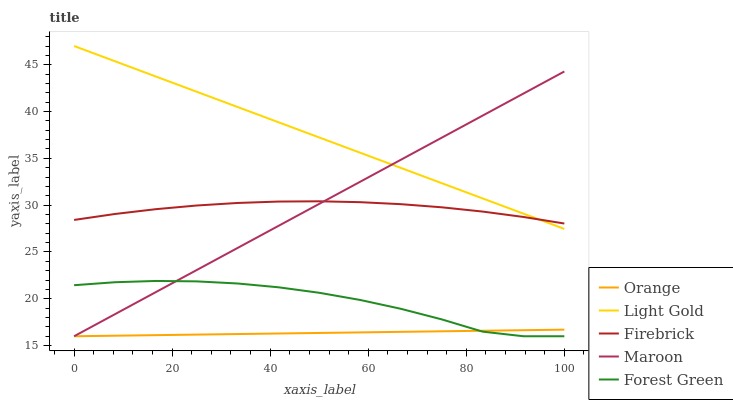Does Orange have the minimum area under the curve?
Answer yes or no. Yes. Does Light Gold have the maximum area under the curve?
Answer yes or no. Yes. Does Firebrick have the minimum area under the curve?
Answer yes or no. No. Does Firebrick have the maximum area under the curve?
Answer yes or no. No. Is Maroon the smoothest?
Answer yes or no. Yes. Is Forest Green the roughest?
Answer yes or no. Yes. Is Firebrick the smoothest?
Answer yes or no. No. Is Firebrick the roughest?
Answer yes or no. No. Does Orange have the lowest value?
Answer yes or no. Yes. Does Light Gold have the lowest value?
Answer yes or no. No. Does Light Gold have the highest value?
Answer yes or no. Yes. Does Firebrick have the highest value?
Answer yes or no. No. Is Forest Green less than Firebrick?
Answer yes or no. Yes. Is Light Gold greater than Forest Green?
Answer yes or no. Yes. Does Forest Green intersect Maroon?
Answer yes or no. Yes. Is Forest Green less than Maroon?
Answer yes or no. No. Is Forest Green greater than Maroon?
Answer yes or no. No. Does Forest Green intersect Firebrick?
Answer yes or no. No. 